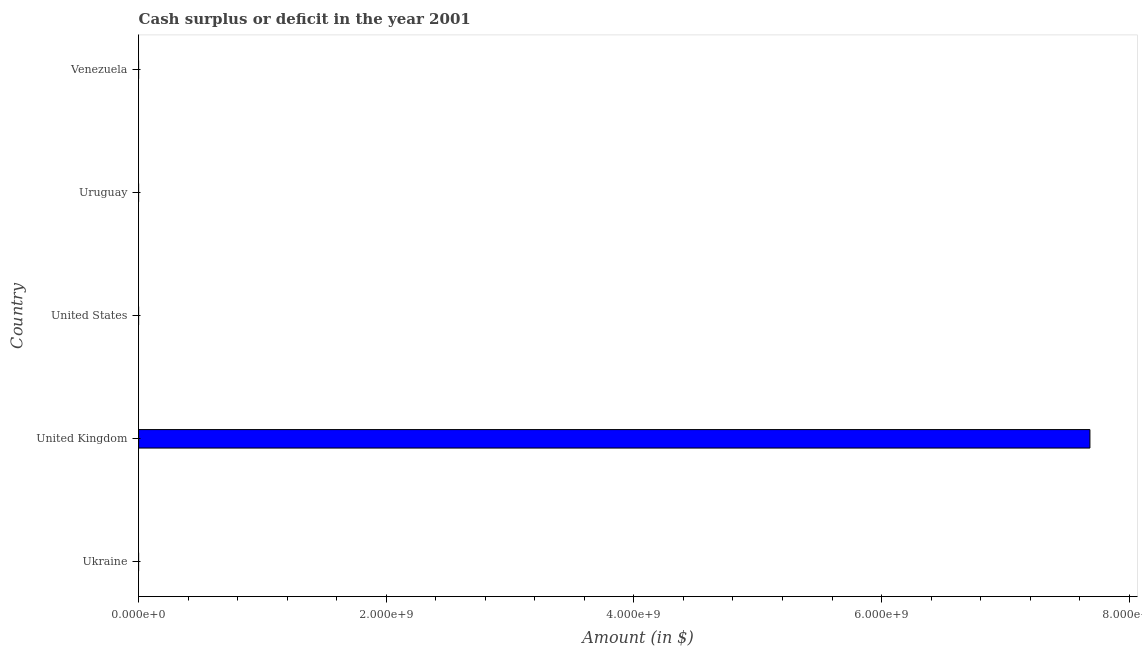Does the graph contain grids?
Make the answer very short. No. What is the title of the graph?
Keep it short and to the point. Cash surplus or deficit in the year 2001. What is the label or title of the X-axis?
Give a very brief answer. Amount (in $). What is the cash surplus or deficit in United Kingdom?
Provide a succinct answer. 7.68e+09. Across all countries, what is the maximum cash surplus or deficit?
Provide a short and direct response. 7.68e+09. In which country was the cash surplus or deficit maximum?
Keep it short and to the point. United Kingdom. What is the sum of the cash surplus or deficit?
Keep it short and to the point. 7.68e+09. What is the average cash surplus or deficit per country?
Ensure brevity in your answer.  1.54e+09. What is the median cash surplus or deficit?
Offer a terse response. 0. What is the difference between the highest and the lowest cash surplus or deficit?
Provide a succinct answer. 7.68e+09. Are all the bars in the graph horizontal?
Your answer should be compact. Yes. What is the Amount (in $) of Ukraine?
Give a very brief answer. 0. What is the Amount (in $) in United Kingdom?
Provide a short and direct response. 7.68e+09. What is the Amount (in $) of United States?
Your answer should be compact. 0. What is the Amount (in $) in Uruguay?
Your response must be concise. 0. What is the Amount (in $) of Venezuela?
Ensure brevity in your answer.  0. 